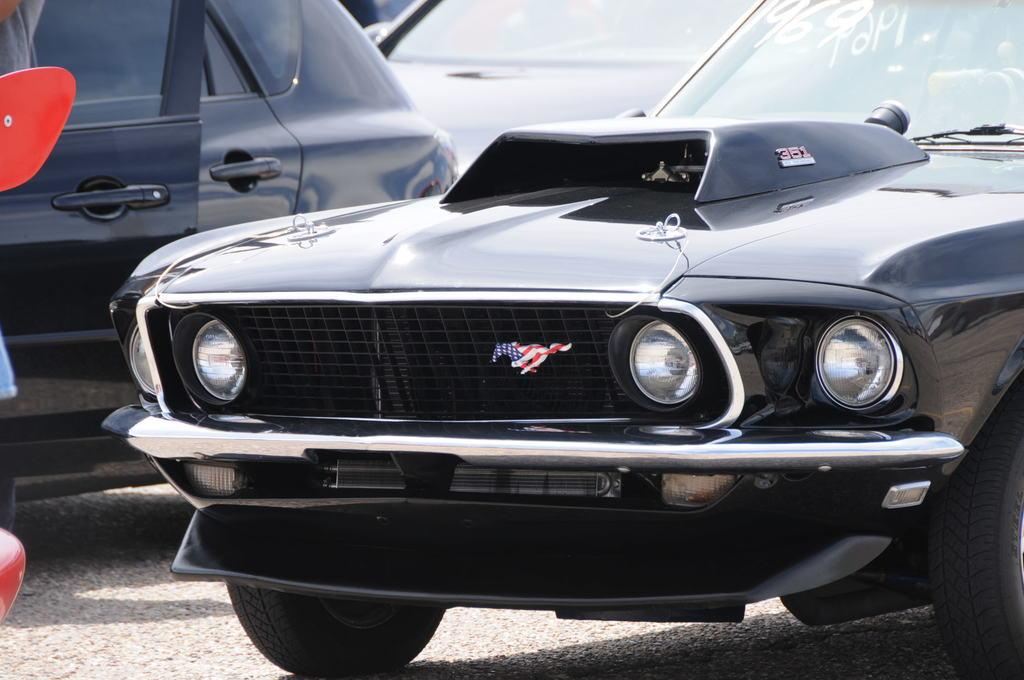What type of objects are on the ground in the image? There are vehicles on the ground in the image. What color are the vehicles? The vehicles are black in color. What can be seen on the left side of the image? There are objects on the left side of the image. What type of board is being used by the vehicles in the image? There is no board present in the image, and the vehicles are not using any board. Can you tell me how many combs are visible in the image? There are no combs present in the image. 